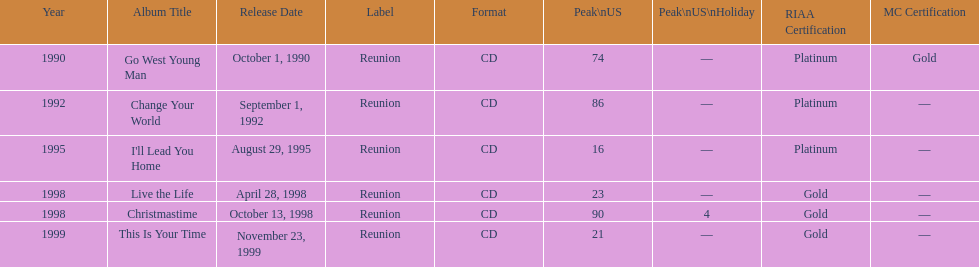How many songs are listed from 1998? 2. 